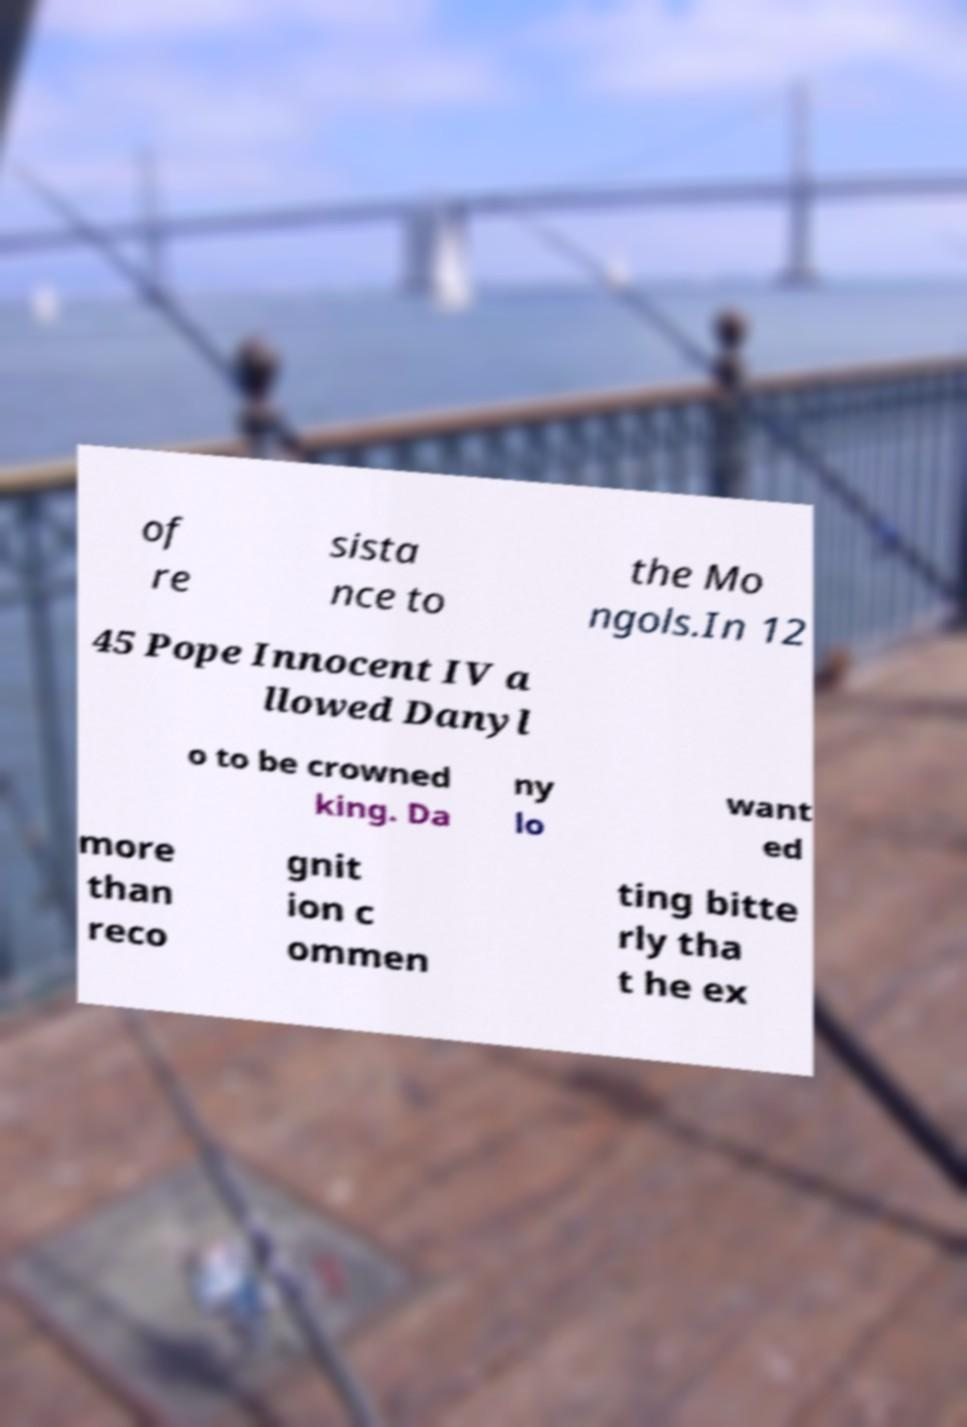There's text embedded in this image that I need extracted. Can you transcribe it verbatim? of re sista nce to the Mo ngols.In 12 45 Pope Innocent IV a llowed Danyl o to be crowned king. Da ny lo want ed more than reco gnit ion c ommen ting bitte rly tha t he ex 